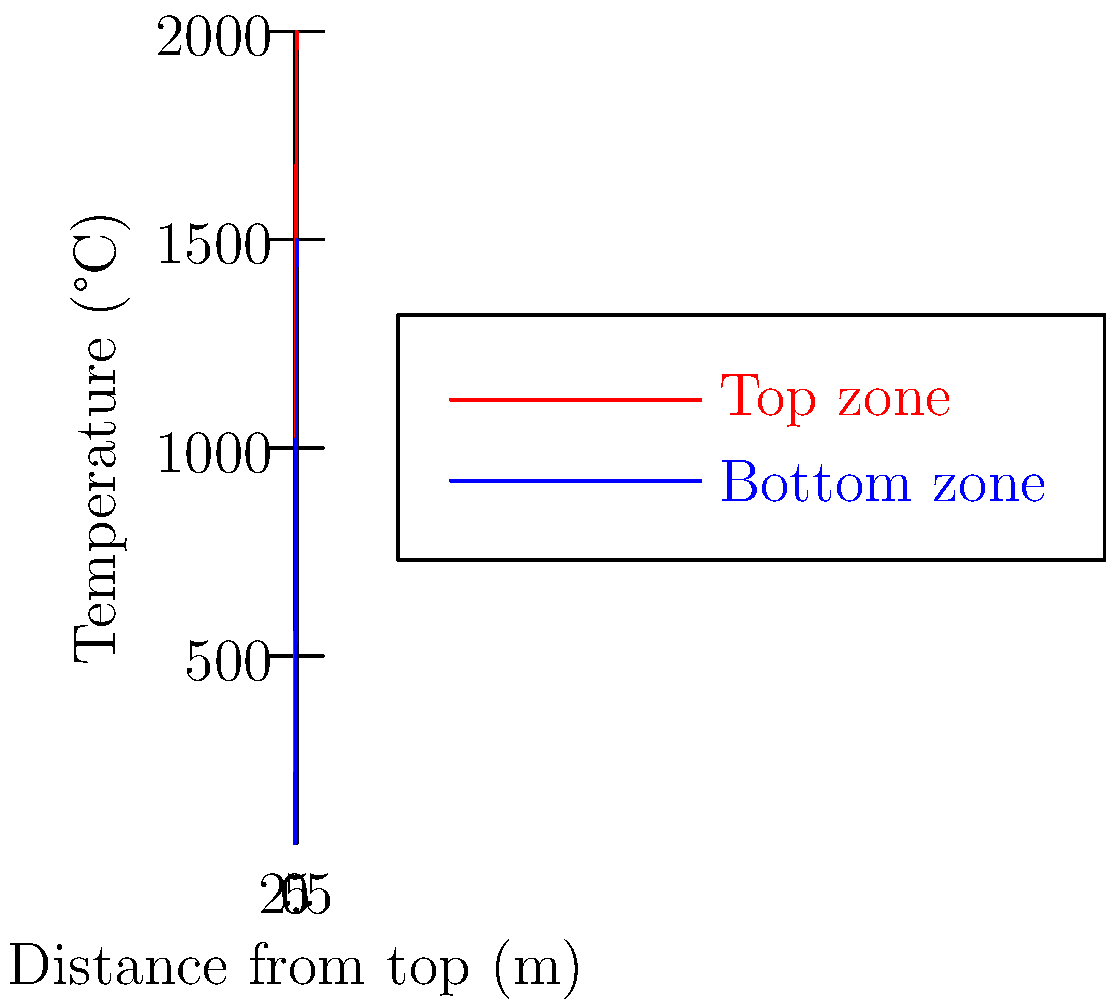Based on the temperature graph of a blast furnace, at approximately what distance from the top does the temperature difference between the top and bottom zones reach its maximum? To find the point of maximum temperature difference between the top and bottom zones, we need to follow these steps:

1. Observe the two curves: red represents the top zone, and blue represents the bottom zone.
2. Mentally calculate the vertical distance between the two curves at various points.
3. Identify where this vertical distance appears largest.
4. Estimate the corresponding distance on the x-axis.

Looking at the graph:
- At 0m, the difference is small.
- The gap widens as we move right.
- The maximum gap appears to be around 3-4m from the top.
- After this point, the curves start to converge slightly.

The largest vertical gap, representing the maximum temperature difference, occurs at approximately 3.5m from the top of the furnace.
Answer: Approximately 3.5m from the top 